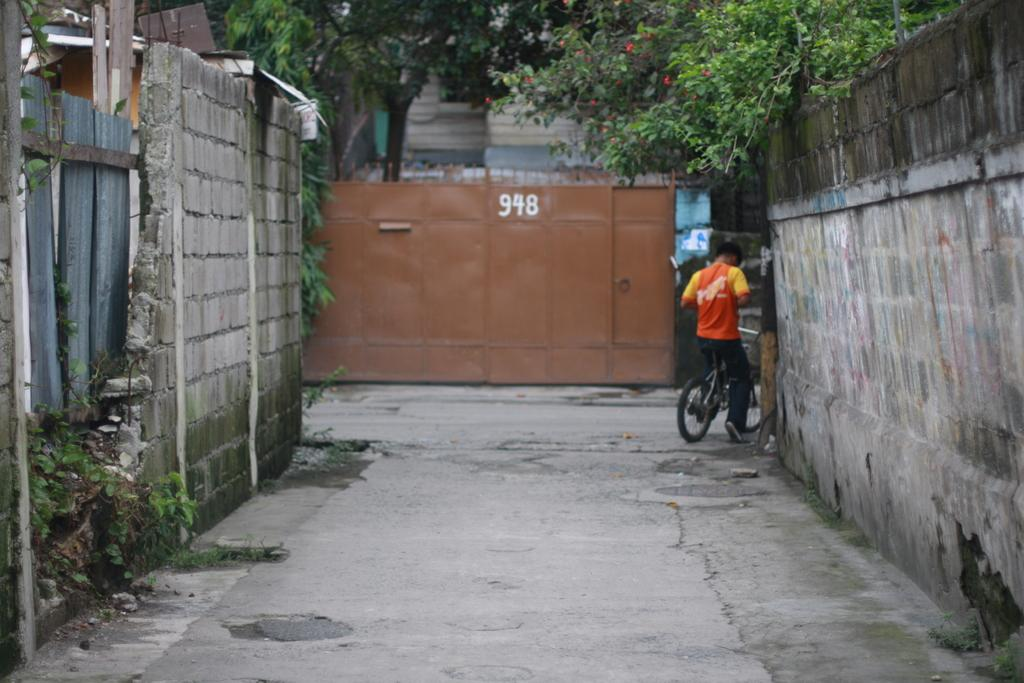Provide a one-sentence caption for the provided image. A man riding a bike down an alleyway with the numbers 948 written on a wall at the far end. 